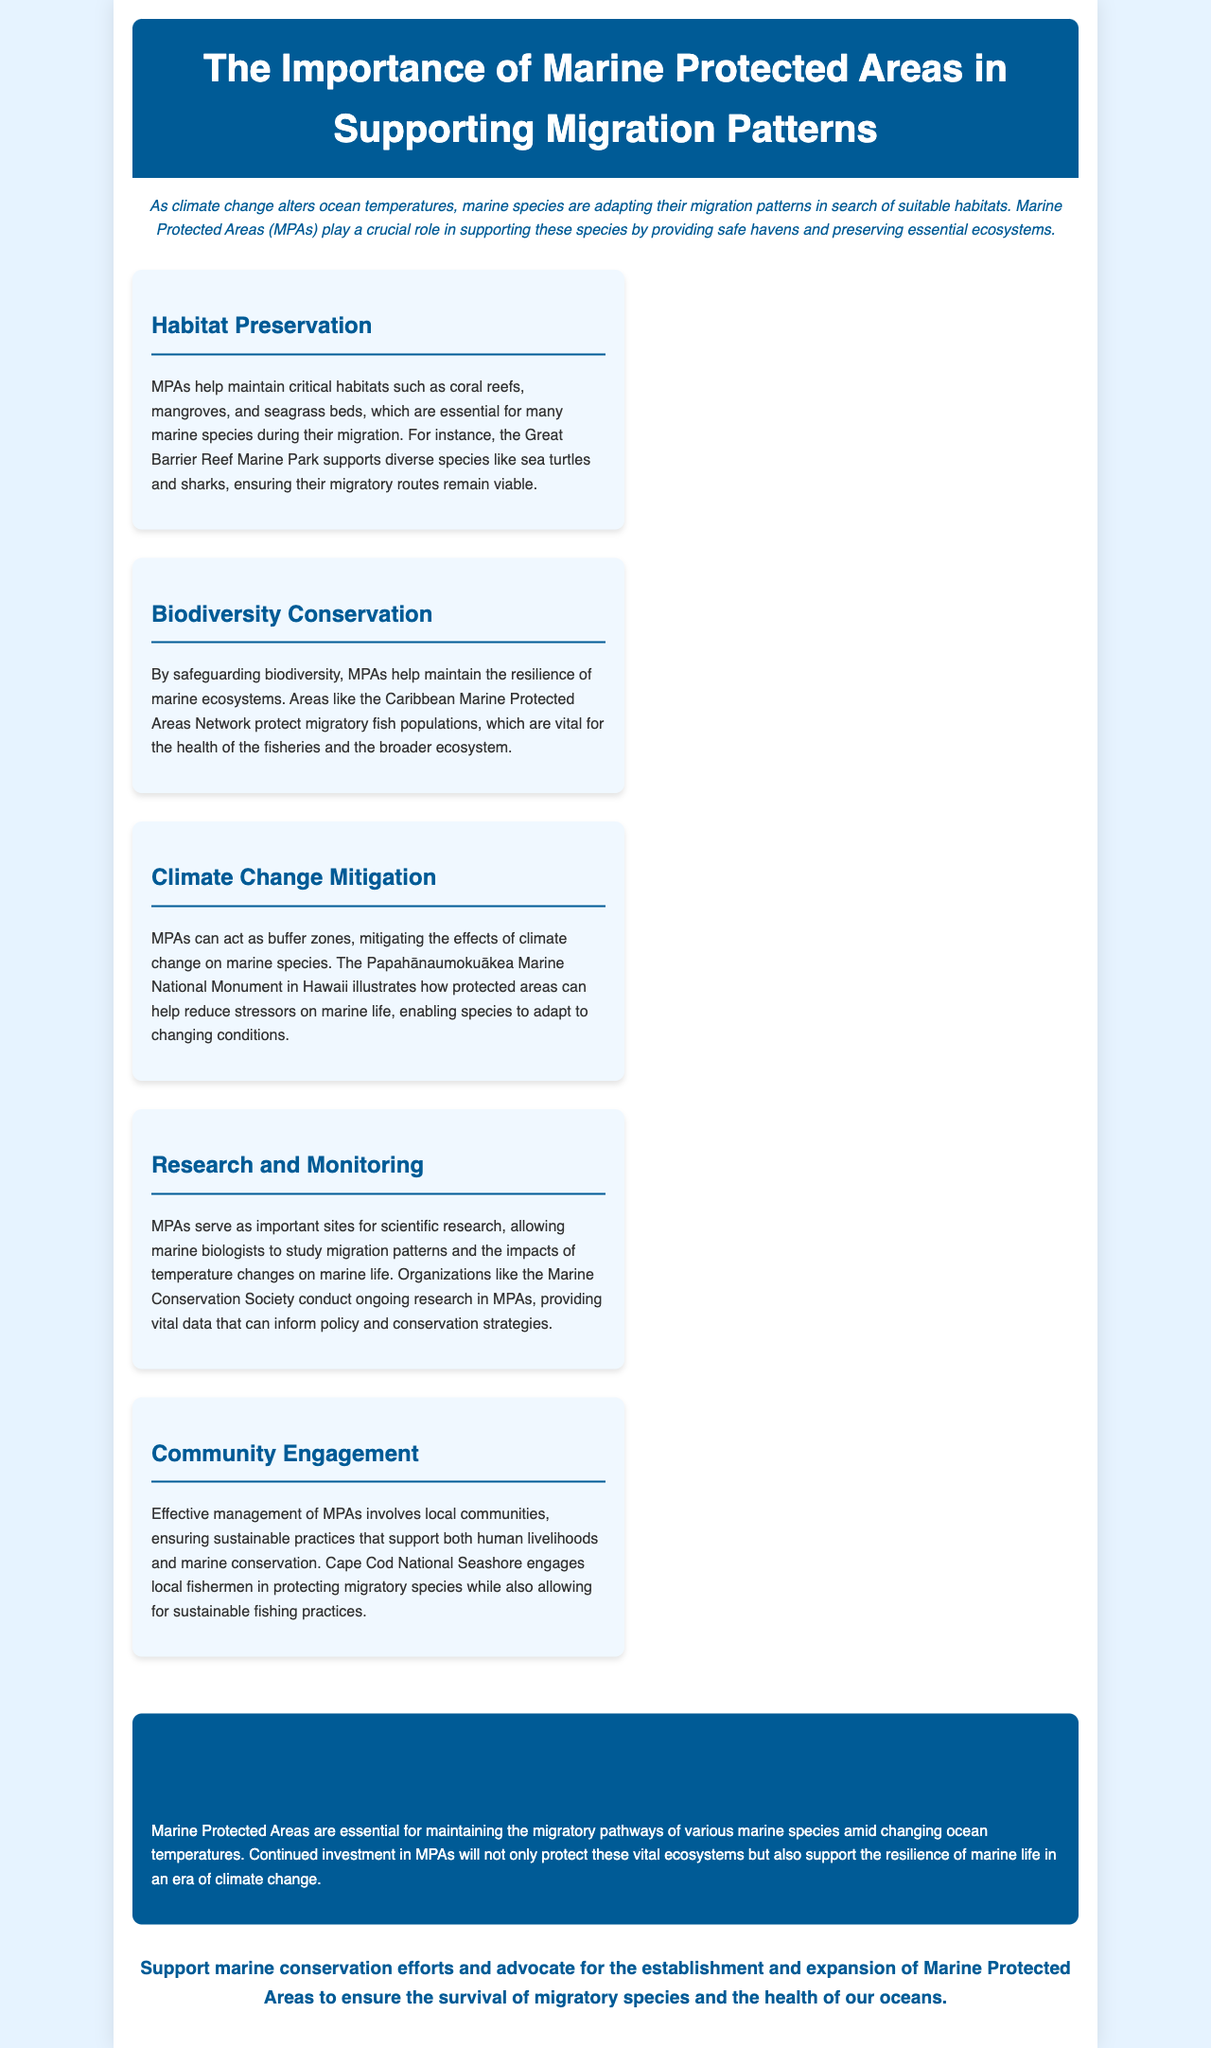What is the title of the document? The title is clearly stated at the top of the document in the header section.
Answer: The Importance of Marine Protected Areas in Supporting Migration Patterns What role do MPAs play in migration? The introduction outlines the vital function of MPAs in relation to species adapting their migration patterns.
Answer: Providing safe havens Which marine area is mentioned for habitat preservation? The point on habitat preservation specifically names a notable marine area that supports diverse species.
Answer: Great Barrier Reef Marine Park What is the function of MPAs regarding biodiversity? The point on biodiversity conservation explains how MPAs contribute to ecosystem resilience.
Answer: Safeguarding biodiversity Which marine protected area is cited for climate change mitigation? The text discusses a specific marine monument in Hawaii that exemplifies successful climate change mitigation efforts.
Answer: Papahānaumokuākea Marine National Monument How do MPAs contribute to research? The document explains the significance of MPAs for ongoing scientific studies regarding migration patterns.
Answer: Important sites for scientific research What kind of engagement is highlighted in MPAs? The section on community engagement emphasizes local community involvement in the management of MPAs.
Answer: Local communities What action does the document encourage readers to take? The call-to-action section provides a clear directive towards supporting marine conservation efforts.
Answer: Advocate for the establishment and expansion of Marine Protected Areas 